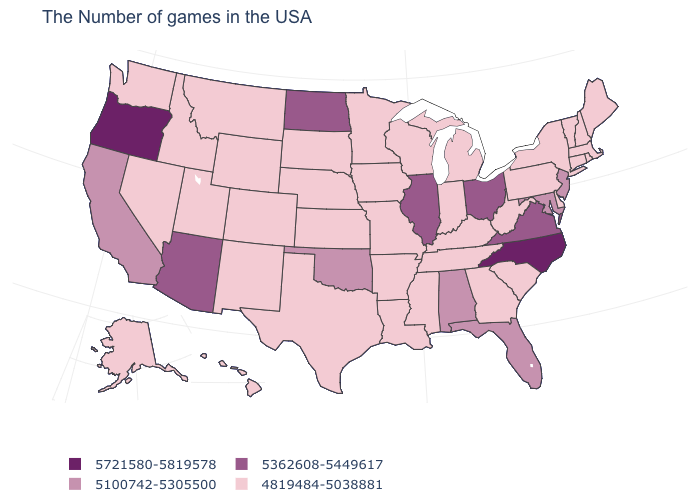Does the map have missing data?
Give a very brief answer. No. Is the legend a continuous bar?
Quick response, please. No. What is the value of Connecticut?
Give a very brief answer. 4819484-5038881. Which states have the lowest value in the West?
Concise answer only. Wyoming, Colorado, New Mexico, Utah, Montana, Idaho, Nevada, Washington, Alaska, Hawaii. Among the states that border South Carolina , does North Carolina have the lowest value?
Write a very short answer. No. What is the lowest value in states that border Michigan?
Quick response, please. 4819484-5038881. What is the highest value in the USA?
Quick response, please. 5721580-5819578. What is the value of New Hampshire?
Be succinct. 4819484-5038881. What is the value of Delaware?
Keep it brief. 4819484-5038881. Does Wyoming have the highest value in the West?
Keep it brief. No. Name the states that have a value in the range 5721580-5819578?
Keep it brief. North Carolina, Oregon. Does Ohio have a lower value than Kentucky?
Be succinct. No. What is the value of Ohio?
Write a very short answer. 5362608-5449617. Among the states that border South Carolina , does Georgia have the lowest value?
Give a very brief answer. Yes. What is the lowest value in states that border Massachusetts?
Short answer required. 4819484-5038881. 